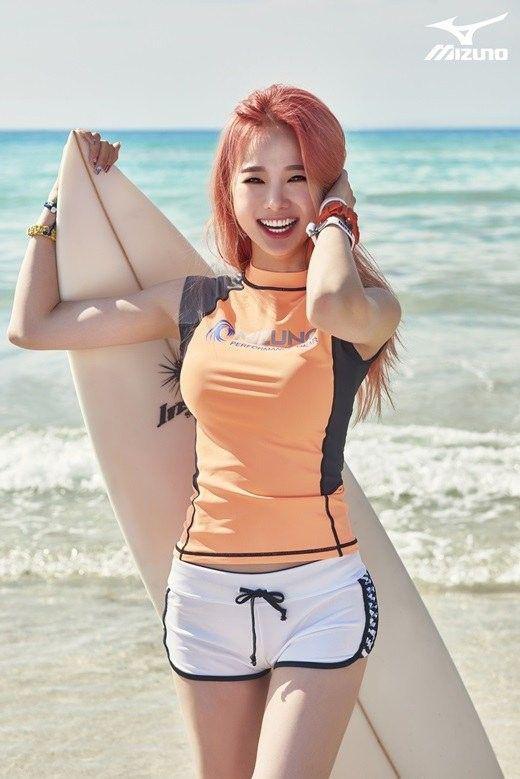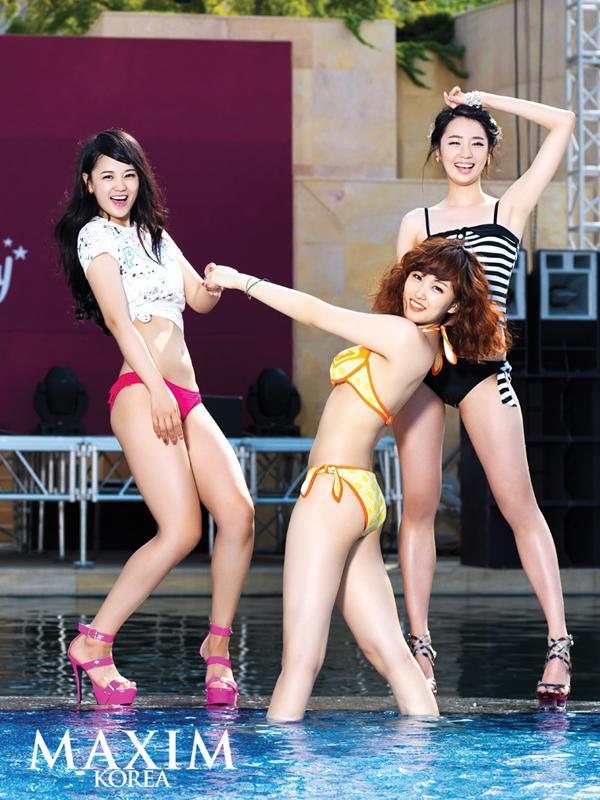The first image is the image on the left, the second image is the image on the right. Analyze the images presented: Is the assertion "The left and right image contains the same number of women in bikinis." valid? Answer yes or no. No. The first image is the image on the left, the second image is the image on the right. Given the left and right images, does the statement "The bikini-clad girls are wearing high heels in the pool." hold true? Answer yes or no. Yes. 